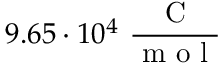Convert formula to latex. <formula><loc_0><loc_0><loc_500><loc_500>9 . 6 5 \cdot 1 0 ^ { 4 } \ \frac { C } { m o l }</formula> 